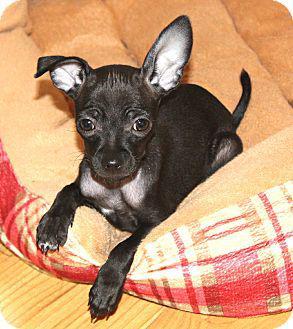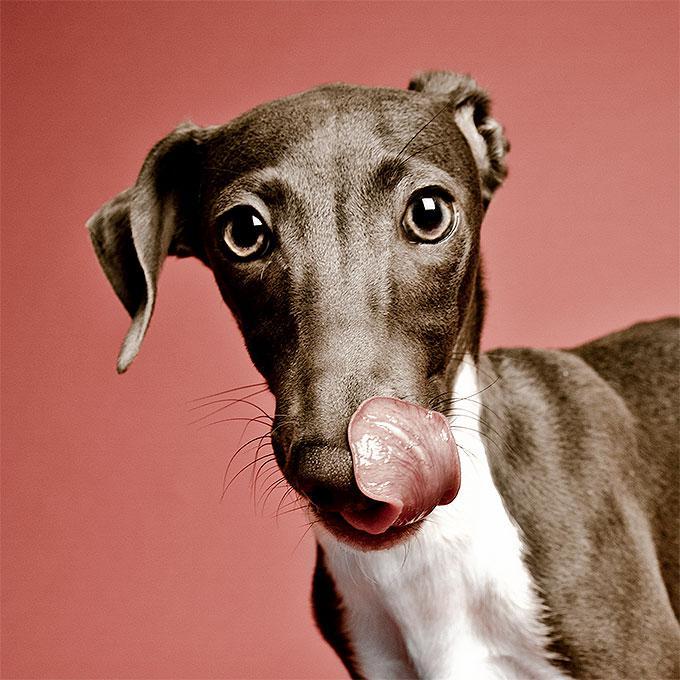The first image is the image on the left, the second image is the image on the right. Analyze the images presented: Is the assertion "In one image, a dog's very long tongue is outside of its mouth and at least one ear is pulled towards the back of its head." valid? Answer yes or no. Yes. The first image is the image on the left, the second image is the image on the right. Given the left and right images, does the statement "The dog in one of the images is sitting on a soft surface." hold true? Answer yes or no. Yes. 